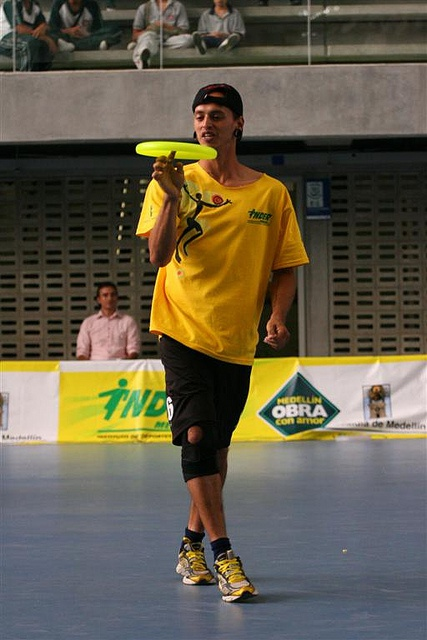Describe the objects in this image and their specific colors. I can see people in gray, black, olive, maroon, and orange tones, people in gray, lightpink, brown, maroon, and salmon tones, people in gray, darkgray, and black tones, people in gray and black tones, and frisbee in gray, yellow, gold, and khaki tones in this image. 